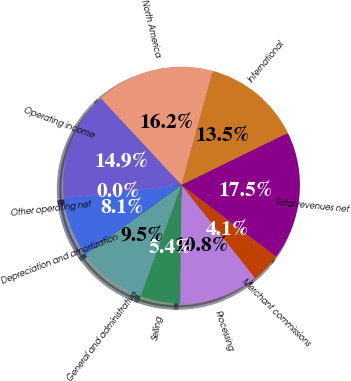Convert chart. <chart><loc_0><loc_0><loc_500><loc_500><pie_chart><fcel>North America<fcel>International<fcel>Total revenues net<fcel>Merchant commissions<fcel>Processing<fcel>Selling<fcel>General and administrative<fcel>Depreciation and amortization<fcel>Other operating net<fcel>Operating income<nl><fcel>16.2%<fcel>13.5%<fcel>17.54%<fcel>4.07%<fcel>10.81%<fcel>5.42%<fcel>9.46%<fcel>8.11%<fcel>0.03%<fcel>14.85%<nl></chart> 